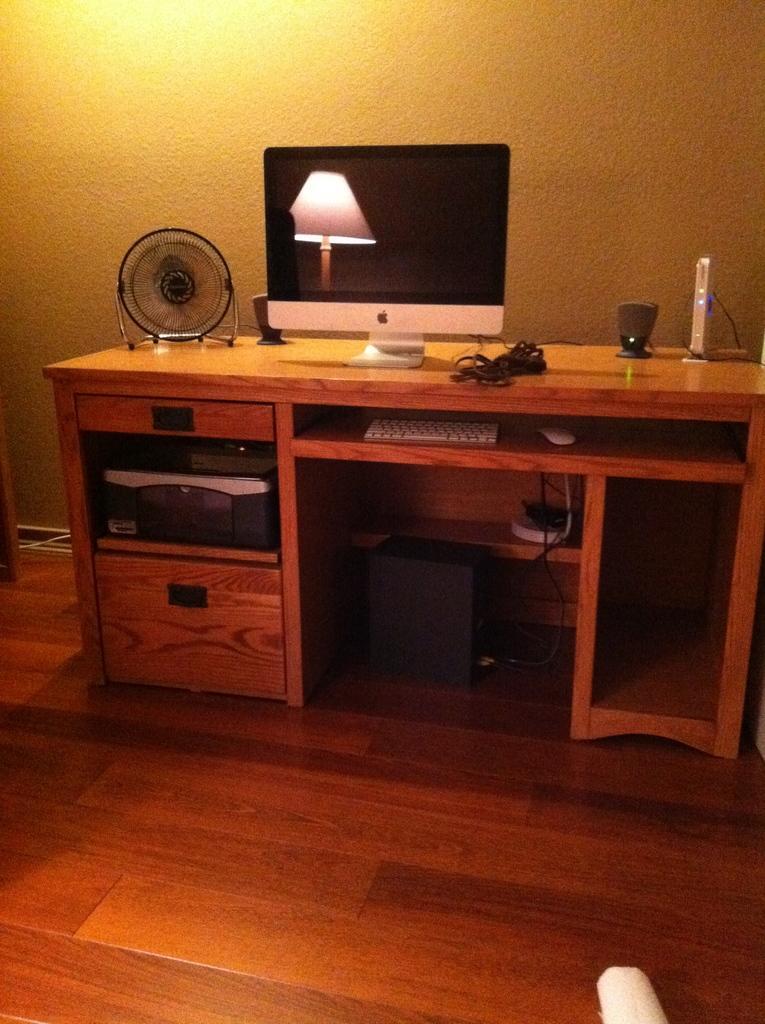Describe this image in one or two sentences. This image is clicked in a room. At the bottom, there is a floor made up of wood. In the front, we can see a wooden table. On which, there is a computer along with speakers and a small fan. At the bottom, there are drawers. In the background, there is a wall. 